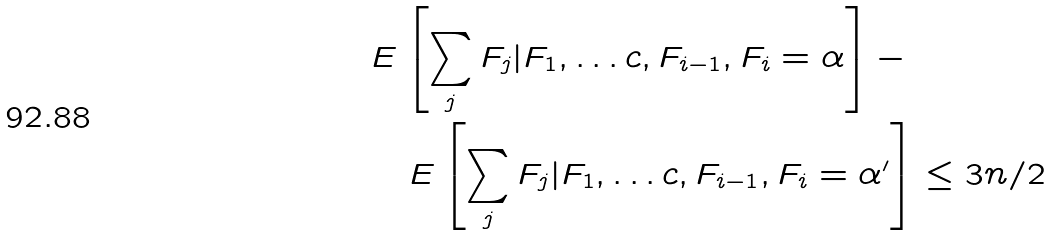Convert formula to latex. <formula><loc_0><loc_0><loc_500><loc_500>& E \left [ \sum _ { j } F _ { j } | F _ { 1 } , \dots c , F _ { i - 1 } , F _ { i } = \alpha \right ] - \\ & \quad E \left [ \sum _ { j } F _ { j } | F _ { 1 } , \dots c , F _ { i - 1 } , F _ { i } = \alpha ^ { \prime } \right ] \leq 3 n / 2</formula> 